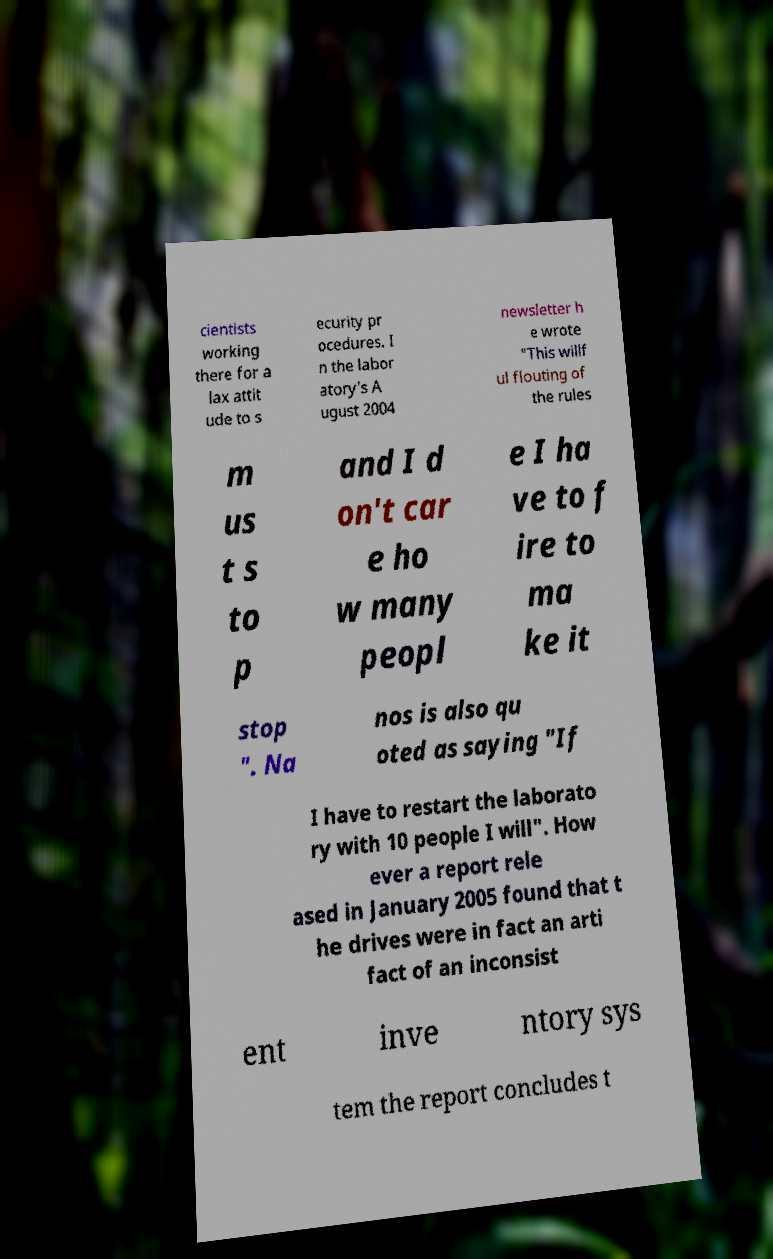Could you extract and type out the text from this image? cientists working there for a lax attit ude to s ecurity pr ocedures. I n the labor atory's A ugust 2004 newsletter h e wrote "This willf ul flouting of the rules m us t s to p and I d on't car e ho w many peopl e I ha ve to f ire to ma ke it stop ". Na nos is also qu oted as saying "If I have to restart the laborato ry with 10 people I will". How ever a report rele ased in January 2005 found that t he drives were in fact an arti fact of an inconsist ent inve ntory sys tem the report concludes t 